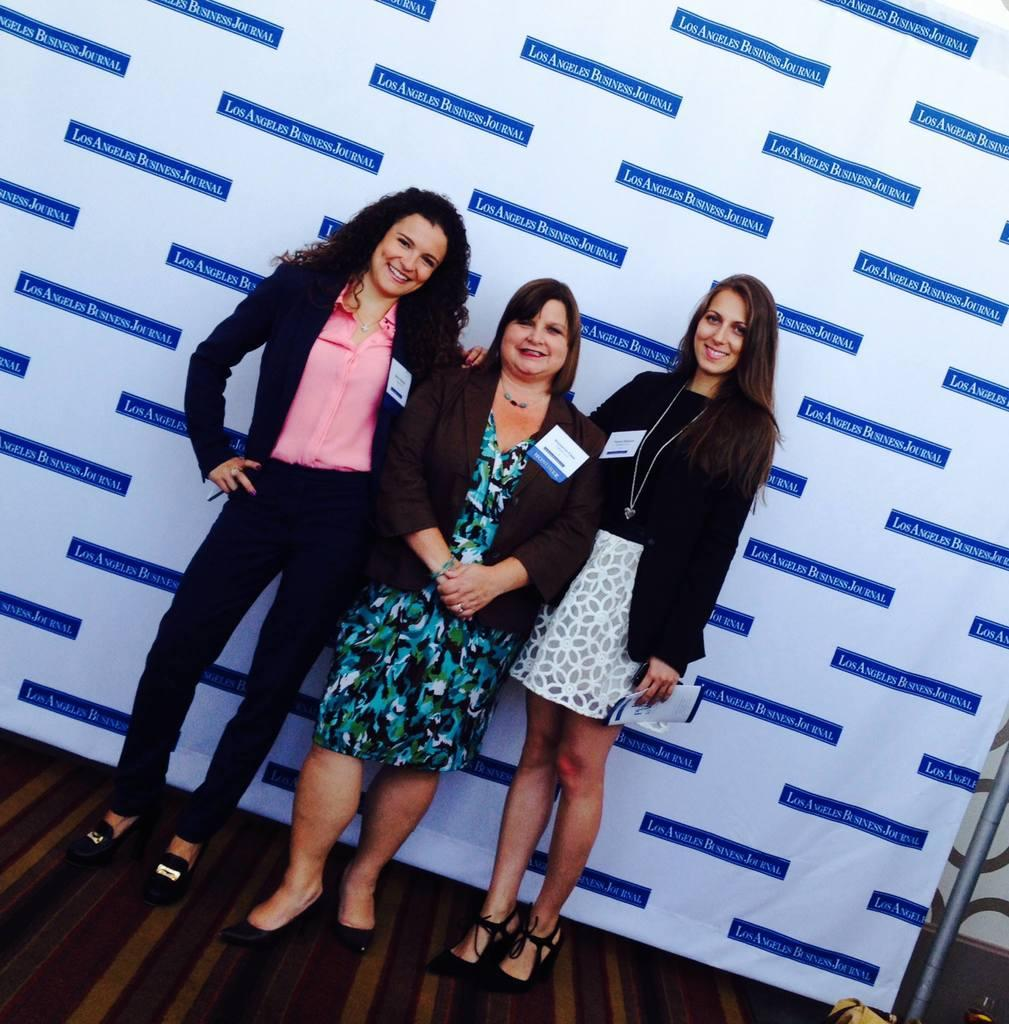How many women are in the image? There are three women in the image. What are the women wearing? The women are wearing black jackets. What are the women doing in the image? The women are standing. What can be seen beneath the women's feet in the image? There is a floor visible in the image. What is in the background of the image? There is a banner in the background of the image. What object is on the right side of the image? There is a rod on the right side of the image. What type of apparel is the women using to grow plants in the image? There is no apparel or plants present in the image; the women are wearing black jackets and standing. How many beds can be seen in the image? There are no beds present in the image. 